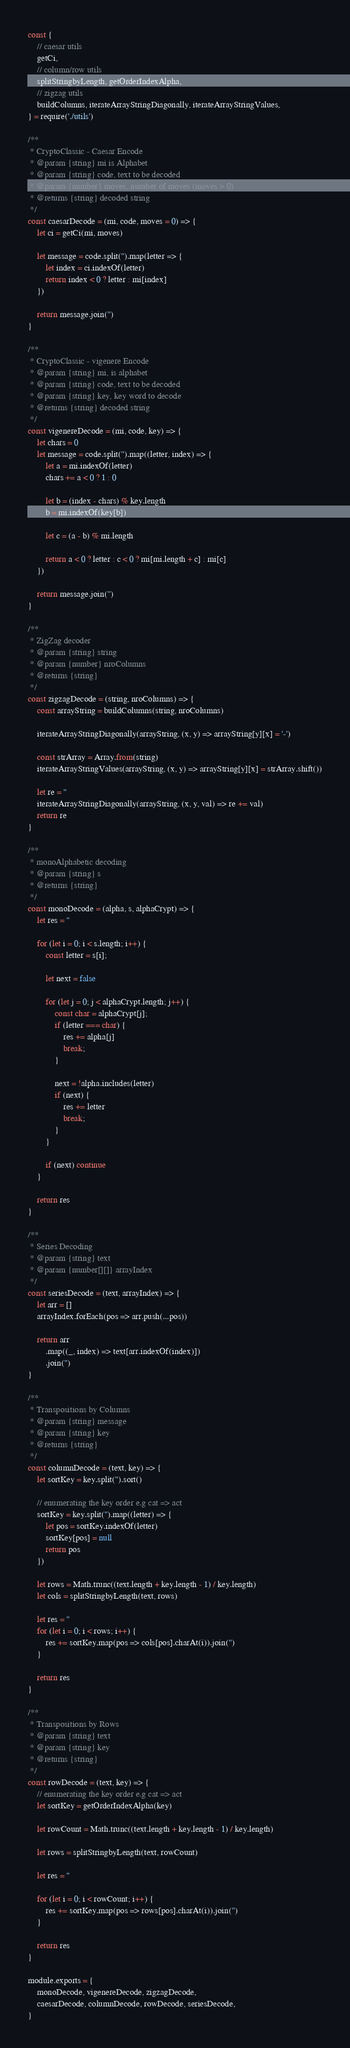<code> <loc_0><loc_0><loc_500><loc_500><_JavaScript_>const {
    // caesar utils
    getCi,
    // column/row utils
    splitStringbyLength, getOrderIndexAlpha,
    // zigzag utils
    buildColumns, iterateArrayStringDiagonally, iterateArrayStringValues,
} = require('./utils')

/**
 * CryptoClassic - Caesar Encode
 * @param {string} mi is Alphabet
 * @param {string} code, text to be decoded
 * @param {number} moves, number of moves (moves > 0)
 * @returns {string} decoded string
 */
const caesarDecode = (mi, code, moves = 0) => {
    let ci = getCi(mi, moves)

    let message = code.split('').map(letter => {
        let index = ci.indexOf(letter)
        return index < 0 ? letter : mi[index]
    })

    return message.join('')
}

/**
 * CryptoClassic - vigenere Encode
 * @param {string} mi, is alphabet
 * @param {string} code, text to be decoded
 * @param {string} key, key word to decode 
 * @returns {string} decoded string
 */
const vigenereDecode = (mi, code, key) => {
    let chars = 0
    let message = code.split('').map((letter, index) => {
        let a = mi.indexOf(letter)
        chars += a < 0 ? 1 : 0

        let b = (index - chars) % key.length
        b = mi.indexOf(key[b])

        let c = (a - b) % mi.length

        return a < 0 ? letter : c < 0 ? mi[mi.length + c] : mi[c]
    })

    return message.join('')
}

/**
 * ZigZag decoder
 * @param {string} string 
 * @param {number} nroColumns 
 * @returns {string}
 */
const zigzagDecode = (string, nroColumns) => {
    const arrayString = buildColumns(string, nroColumns)

    iterateArrayStringDiagonally(arrayString, (x, y) => arrayString[y][x] = '-')

    const strArray = Array.from(string)
    iterateArrayStringValues(arrayString, (x, y) => arrayString[y][x] = strArray.shift())

    let re = ''
    iterateArrayStringDiagonally(arrayString, (x, y, val) => re += val)
    return re
}

/**
 * monoAlphabetic decoding 
 * @param {string} s 
 * @returns {string}
 */
const monoDecode = (alpha, s, alphaCrypt) => {
    let res = ''

    for (let i = 0; i < s.length; i++) {
        const letter = s[i];

        let next = false

        for (let j = 0; j < alphaCrypt.length; j++) {
            const char = alphaCrypt[j];
            if (letter === char) {
                res += alpha[j]
                break;
            }

            next = !alpha.includes(letter)
            if (next) {
                res += letter
                break;
            }
        }

        if (next) continue
    }

    return res
}

/**
 * Series Decoding
 * @param {string} text 
 * @param {number[][]} arrayIndex 
 */
const seriesDecode = (text, arrayIndex) => {
    let arr = []
    arrayIndex.forEach(pos => arr.push(...pos))

    return arr
        .map((_, index) => text[arr.indexOf(index)])
        .join('')
}

/**
 * Transpositions by Columns
 * @param {string} message
 * @param {string} key
 * @returns {string}
 */
const columnDecode = (text, key) => {
    let sortKey = key.split('').sort()

    // enumerating the key order e.g cat => act
    sortKey = key.split('').map((letter) => {
        let pos = sortKey.indexOf(letter)
        sortKey[pos] = null
        return pos
    })

    let rows = Math.trunc((text.length + key.length - 1) / key.length)
    let cols = splitStringbyLength(text, rows)

    let res = ''
    for (let i = 0; i < rows; i++) {
        res += sortKey.map(pos => cols[pos].charAt(i)).join('')
    }

    return res
}

/**
 * Transpositions by Rows
 * @param {string} text 
 * @param {string} key 
 * @returns {string}
 */
const rowDecode = (text, key) => {
    // enumerating the key order e.g cat => act
    let sortKey = getOrderIndexAlpha(key)

    let rowCount = Math.trunc((text.length + key.length - 1) / key.length)

    let rows = splitStringbyLength(text, rowCount)

    let res = ''

    for (let i = 0; i < rowCount; i++) {
        res += sortKey.map(pos => rows[pos].charAt(i)).join('')
    }

    return res
}

module.exports = {
    monoDecode, vigenereDecode, zigzagDecode,
    caesarDecode, columnDecode, rowDecode, seriesDecode,
}</code> 